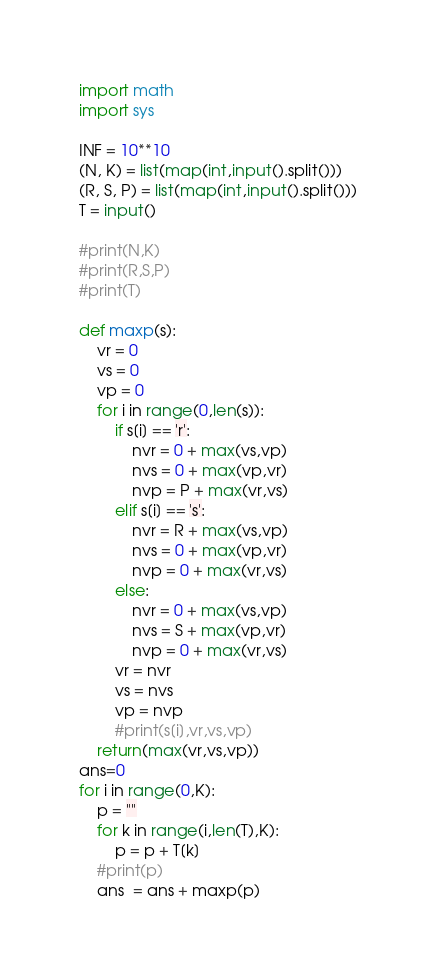Convert code to text. <code><loc_0><loc_0><loc_500><loc_500><_Python_>import math
import sys

INF = 10**10
(N, K) = list(map(int,input().split()))
(R, S, P) = list(map(int,input().split()))
T = input()

#print(N,K)
#print(R,S,P)
#print(T)

def maxp(s):
    vr = 0
    vs = 0
    vp = 0
    for i in range(0,len(s)):
        if s[i] == 'r':
            nvr = 0 + max(vs,vp)
            nvs = 0 + max(vp,vr)
            nvp = P + max(vr,vs)
        elif s[i] == 's':
            nvr = R + max(vs,vp)
            nvs = 0 + max(vp,vr)
            nvp = 0 + max(vr,vs)
        else:
            nvr = 0 + max(vs,vp)
            nvs = S + max(vp,vr)
            nvp = 0 + max(vr,vs)
        vr = nvr
        vs = nvs
        vp = nvp
        #print(s[i],vr,vs,vp)
    return(max(vr,vs,vp))
ans=0
for i in range(0,K):
    p = ""
    for k in range(i,len(T),K):
        p = p + T[k]
    #print(p)
    ans  = ans + maxp(p)</code> 